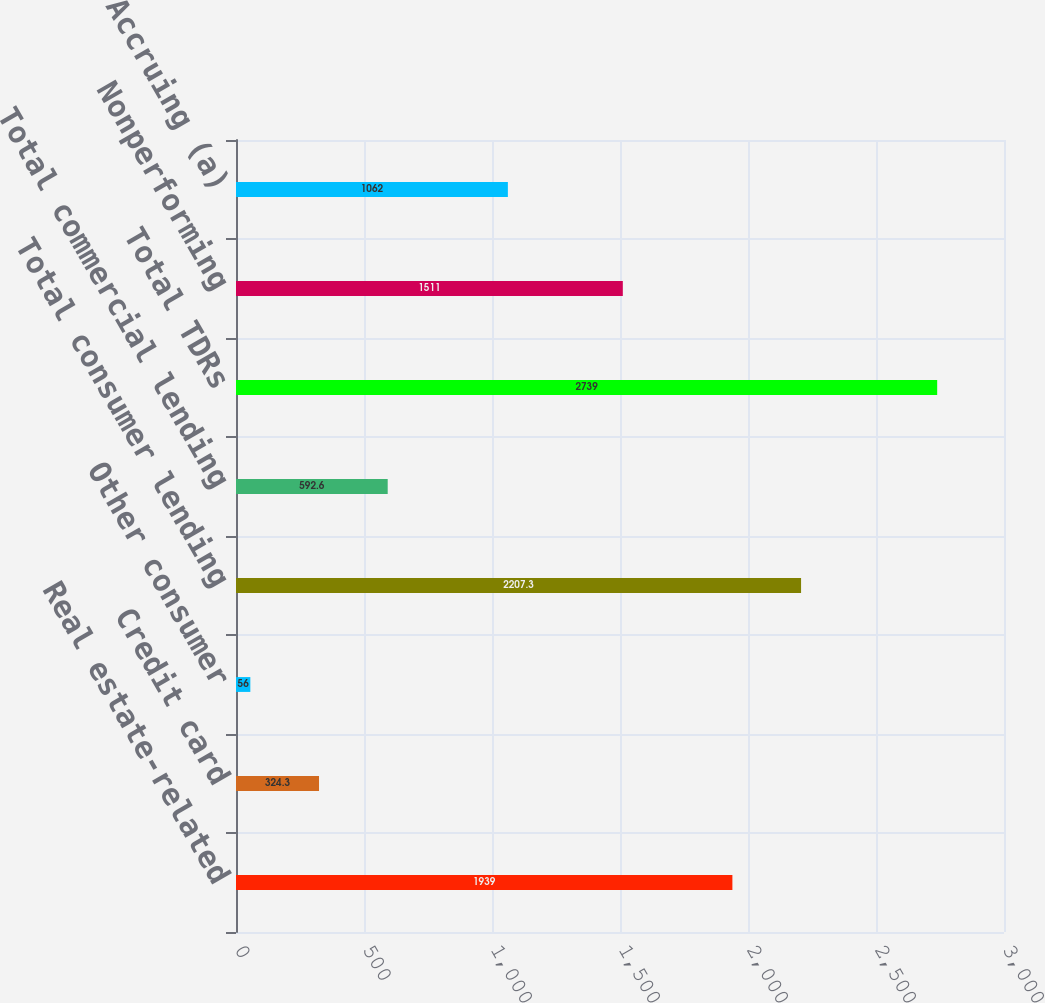<chart> <loc_0><loc_0><loc_500><loc_500><bar_chart><fcel>Real estate-related<fcel>Credit card<fcel>Other consumer<fcel>Total consumer lending<fcel>Total commercial lending<fcel>Total TDRs<fcel>Nonperforming<fcel>Accruing (a)<nl><fcel>1939<fcel>324.3<fcel>56<fcel>2207.3<fcel>592.6<fcel>2739<fcel>1511<fcel>1062<nl></chart> 